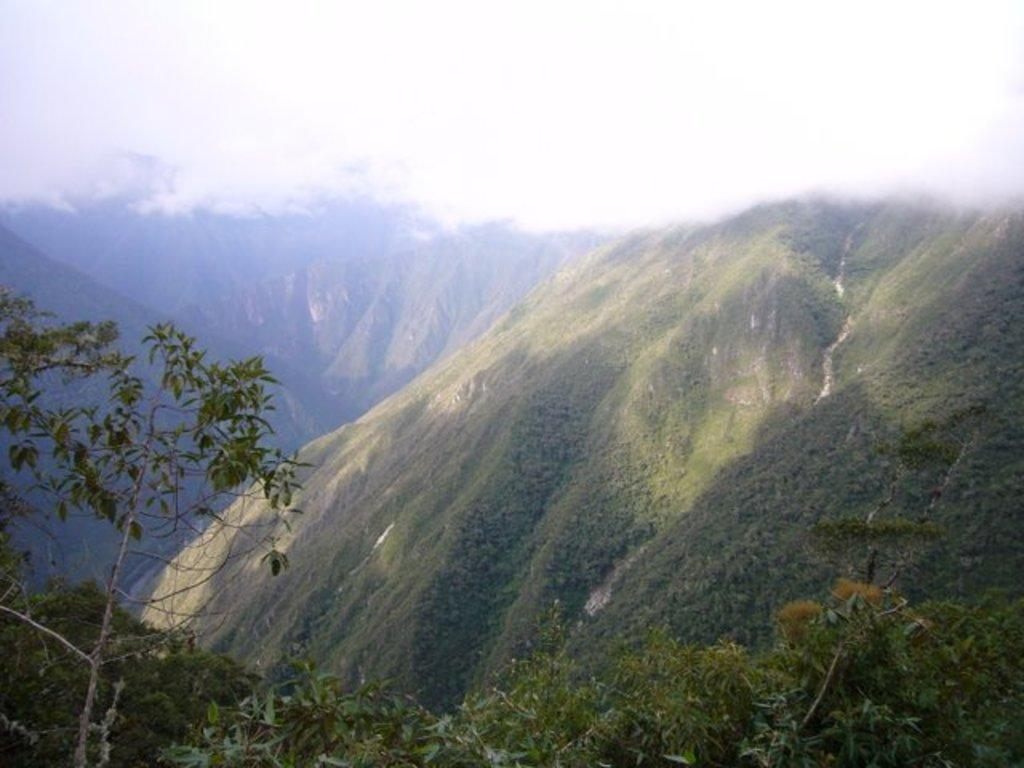What is located in the foreground of the image? There is a group of trees in the foreground of the image. What can be seen in the background of the image? Mountains and the sky are visible in the background of the image. What type of cable can be seen running along the side of the ground in the image? There is no cable visible in the image; it features a group of trees in the foreground and mountains and the sky in the background. 